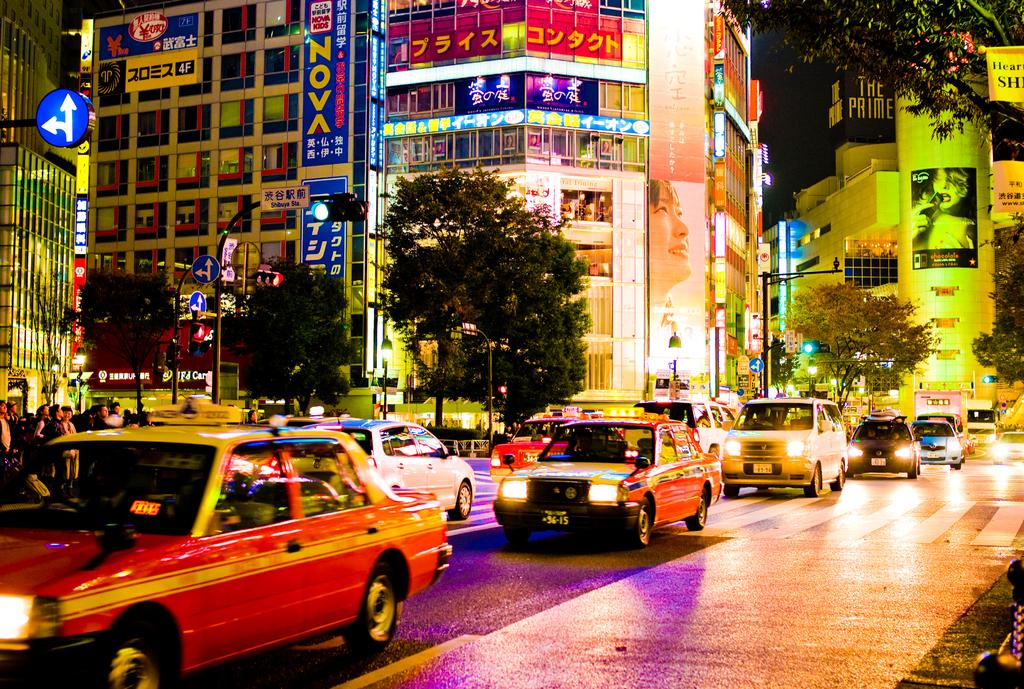<image>
Write a terse but informative summary of the picture. The second red taxi's license plate is 56-15 